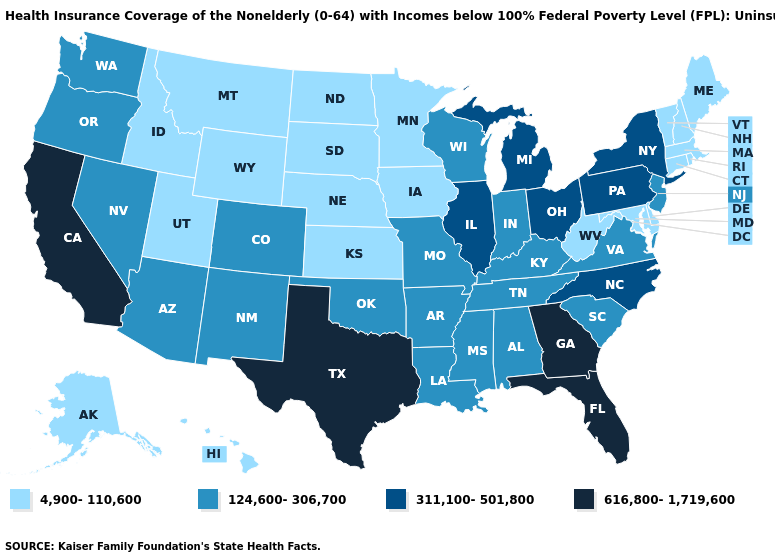How many symbols are there in the legend?
Concise answer only. 4. What is the highest value in states that border South Carolina?
Write a very short answer. 616,800-1,719,600. What is the lowest value in states that border New Mexico?
Keep it brief. 4,900-110,600. What is the value of Wisconsin?
Give a very brief answer. 124,600-306,700. What is the value of Arizona?
Short answer required. 124,600-306,700. Which states hav the highest value in the Northeast?
Keep it brief. New York, Pennsylvania. Name the states that have a value in the range 616,800-1,719,600?
Keep it brief. California, Florida, Georgia, Texas. What is the lowest value in the Northeast?
Answer briefly. 4,900-110,600. What is the highest value in the USA?
Concise answer only. 616,800-1,719,600. Name the states that have a value in the range 124,600-306,700?
Keep it brief. Alabama, Arizona, Arkansas, Colorado, Indiana, Kentucky, Louisiana, Mississippi, Missouri, Nevada, New Jersey, New Mexico, Oklahoma, Oregon, South Carolina, Tennessee, Virginia, Washington, Wisconsin. What is the highest value in the South ?
Short answer required. 616,800-1,719,600. Name the states that have a value in the range 4,900-110,600?
Write a very short answer. Alaska, Connecticut, Delaware, Hawaii, Idaho, Iowa, Kansas, Maine, Maryland, Massachusetts, Minnesota, Montana, Nebraska, New Hampshire, North Dakota, Rhode Island, South Dakota, Utah, Vermont, West Virginia, Wyoming. Among the states that border Kansas , which have the highest value?
Concise answer only. Colorado, Missouri, Oklahoma. Does Utah have a lower value than Connecticut?
Keep it brief. No. What is the value of Louisiana?
Short answer required. 124,600-306,700. 